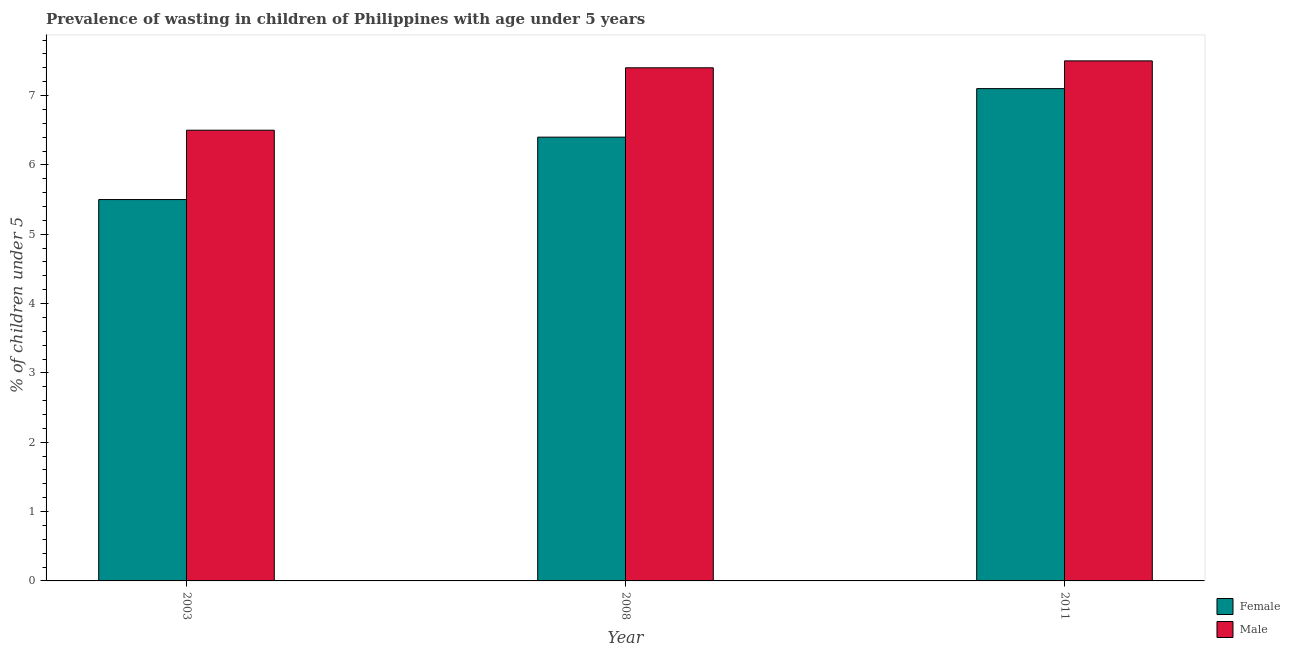How many different coloured bars are there?
Give a very brief answer. 2. Are the number of bars on each tick of the X-axis equal?
Provide a succinct answer. Yes. How many bars are there on the 2nd tick from the left?
Provide a short and direct response. 2. What is the label of the 3rd group of bars from the left?
Offer a very short reply. 2011. What is the percentage of undernourished female children in 2011?
Keep it short and to the point. 7.1. Across all years, what is the maximum percentage of undernourished male children?
Your response must be concise. 7.5. In which year was the percentage of undernourished male children minimum?
Your answer should be very brief. 2003. What is the total percentage of undernourished male children in the graph?
Provide a succinct answer. 21.4. What is the difference between the percentage of undernourished male children in 2003 and that in 2008?
Keep it short and to the point. -0.9. What is the difference between the percentage of undernourished male children in 2011 and the percentage of undernourished female children in 2008?
Offer a terse response. 0.1. What is the average percentage of undernourished male children per year?
Your response must be concise. 7.13. In how many years, is the percentage of undernourished female children greater than 5.2 %?
Provide a short and direct response. 3. What is the ratio of the percentage of undernourished male children in 2008 to that in 2011?
Your answer should be compact. 0.99. What is the difference between the highest and the second highest percentage of undernourished female children?
Your answer should be compact. 0.7. What is the difference between the highest and the lowest percentage of undernourished female children?
Offer a terse response. 1.6. What does the 1st bar from the right in 2008 represents?
Keep it short and to the point. Male. Are all the bars in the graph horizontal?
Your answer should be compact. No. How many years are there in the graph?
Your answer should be very brief. 3. What is the difference between two consecutive major ticks on the Y-axis?
Provide a succinct answer. 1. Are the values on the major ticks of Y-axis written in scientific E-notation?
Ensure brevity in your answer.  No. Where does the legend appear in the graph?
Make the answer very short. Bottom right. How many legend labels are there?
Your answer should be compact. 2. How are the legend labels stacked?
Offer a terse response. Vertical. What is the title of the graph?
Make the answer very short. Prevalence of wasting in children of Philippines with age under 5 years. Does "Investments" appear as one of the legend labels in the graph?
Your answer should be compact. No. What is the label or title of the Y-axis?
Make the answer very short.  % of children under 5. What is the  % of children under 5 of Male in 2003?
Ensure brevity in your answer.  6.5. What is the  % of children under 5 of Female in 2008?
Your answer should be compact. 6.4. What is the  % of children under 5 of Male in 2008?
Offer a terse response. 7.4. What is the  % of children under 5 of Female in 2011?
Offer a very short reply. 7.1. What is the  % of children under 5 in Male in 2011?
Give a very brief answer. 7.5. Across all years, what is the maximum  % of children under 5 of Female?
Your answer should be compact. 7.1. Across all years, what is the maximum  % of children under 5 in Male?
Give a very brief answer. 7.5. Across all years, what is the minimum  % of children under 5 in Female?
Offer a very short reply. 5.5. Across all years, what is the minimum  % of children under 5 in Male?
Ensure brevity in your answer.  6.5. What is the total  % of children under 5 in Female in the graph?
Offer a very short reply. 19. What is the total  % of children under 5 of Male in the graph?
Keep it short and to the point. 21.4. What is the difference between the  % of children under 5 of Female in 2003 and that in 2008?
Make the answer very short. -0.9. What is the difference between the  % of children under 5 in Female in 2003 and that in 2011?
Provide a short and direct response. -1.6. What is the difference between the  % of children under 5 of Male in 2003 and that in 2011?
Provide a succinct answer. -1. What is the difference between the  % of children under 5 in Female in 2008 and that in 2011?
Provide a succinct answer. -0.7. What is the difference between the  % of children under 5 of Female in 2003 and the  % of children under 5 of Male in 2011?
Offer a very short reply. -2. What is the difference between the  % of children under 5 in Female in 2008 and the  % of children under 5 in Male in 2011?
Ensure brevity in your answer.  -1.1. What is the average  % of children under 5 in Female per year?
Offer a very short reply. 6.33. What is the average  % of children under 5 of Male per year?
Your answer should be compact. 7.13. In the year 2003, what is the difference between the  % of children under 5 of Female and  % of children under 5 of Male?
Provide a short and direct response. -1. In the year 2008, what is the difference between the  % of children under 5 of Female and  % of children under 5 of Male?
Offer a very short reply. -1. In the year 2011, what is the difference between the  % of children under 5 of Female and  % of children under 5 of Male?
Make the answer very short. -0.4. What is the ratio of the  % of children under 5 in Female in 2003 to that in 2008?
Your response must be concise. 0.86. What is the ratio of the  % of children under 5 of Male in 2003 to that in 2008?
Ensure brevity in your answer.  0.88. What is the ratio of the  % of children under 5 of Female in 2003 to that in 2011?
Give a very brief answer. 0.77. What is the ratio of the  % of children under 5 in Male in 2003 to that in 2011?
Ensure brevity in your answer.  0.87. What is the ratio of the  % of children under 5 in Female in 2008 to that in 2011?
Offer a terse response. 0.9. What is the ratio of the  % of children under 5 of Male in 2008 to that in 2011?
Make the answer very short. 0.99. What is the difference between the highest and the second highest  % of children under 5 in Female?
Your answer should be compact. 0.7. What is the difference between the highest and the lowest  % of children under 5 of Male?
Your answer should be compact. 1. 